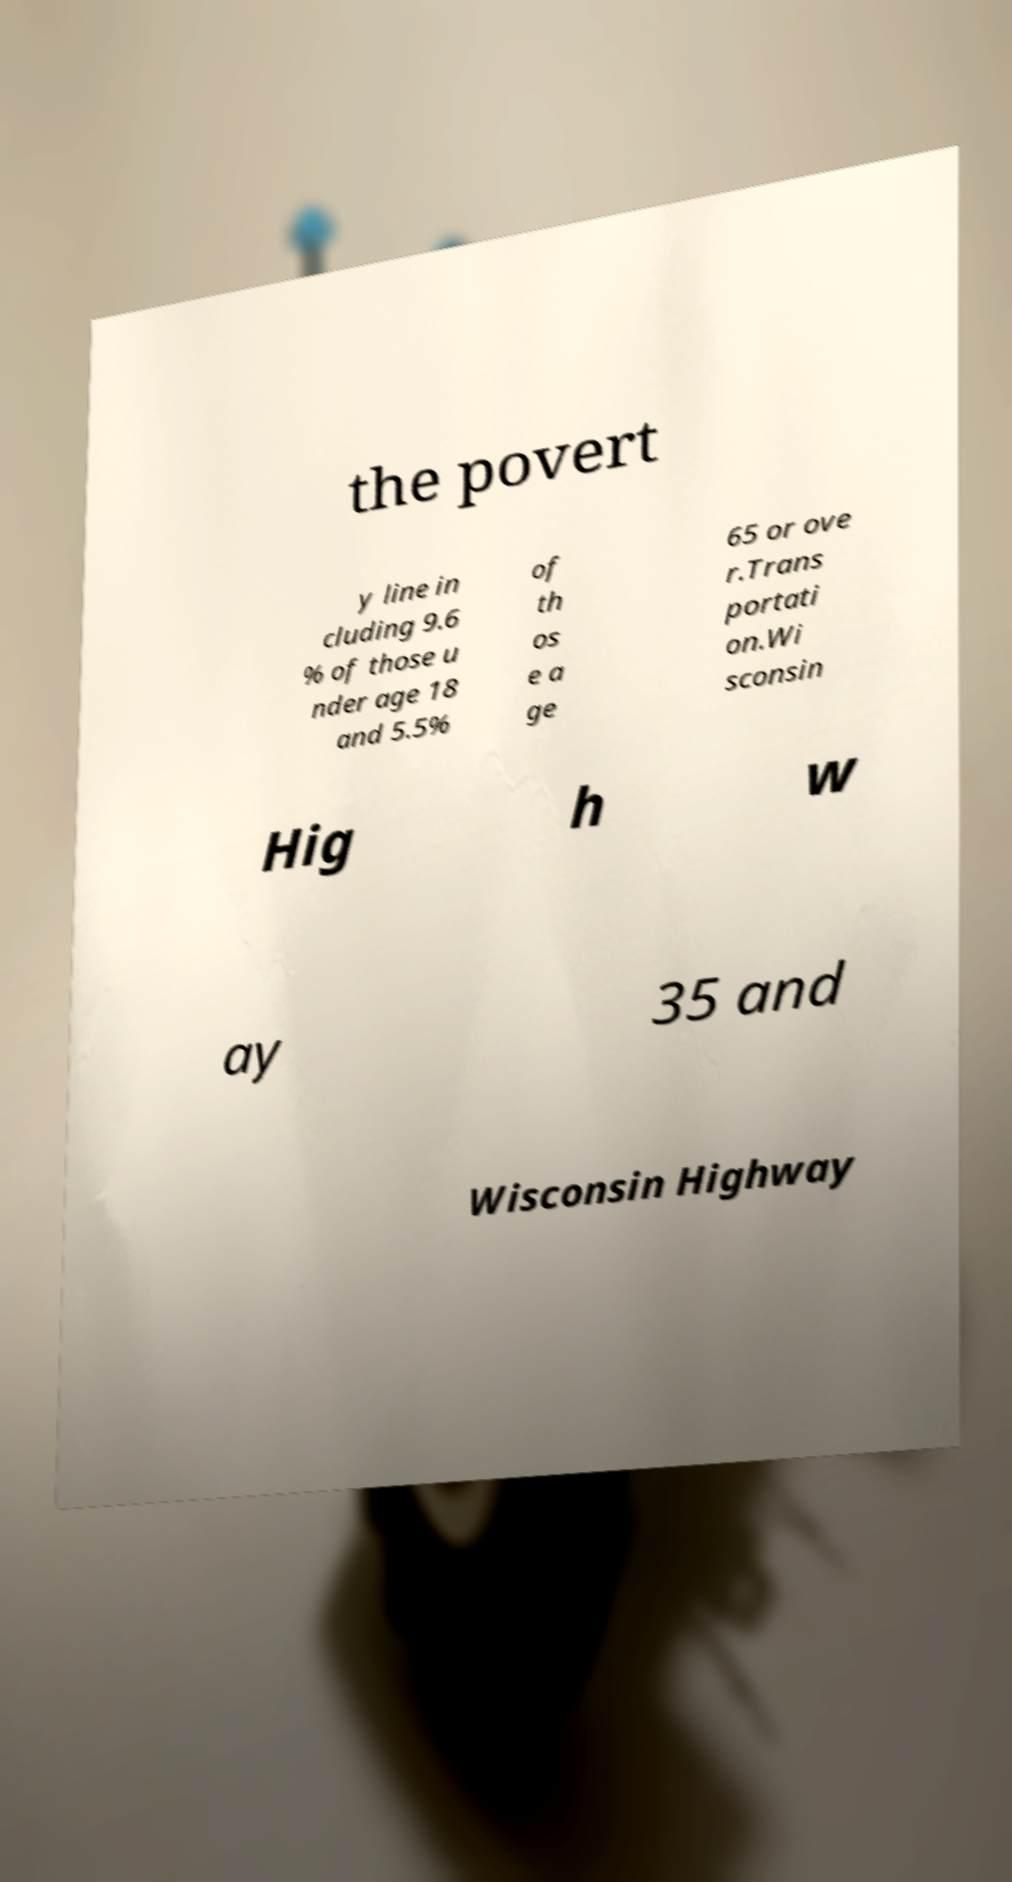Please read and relay the text visible in this image. What does it say? the povert y line in cluding 9.6 % of those u nder age 18 and 5.5% of th os e a ge 65 or ove r.Trans portati on.Wi sconsin Hig h w ay 35 and Wisconsin Highway 